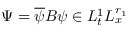Convert formula to latex. <formula><loc_0><loc_0><loc_500><loc_500>\Psi = \overline { \psi } B \psi \in L _ { t } ^ { 1 } L _ { x } ^ { r _ { 1 } }</formula> 